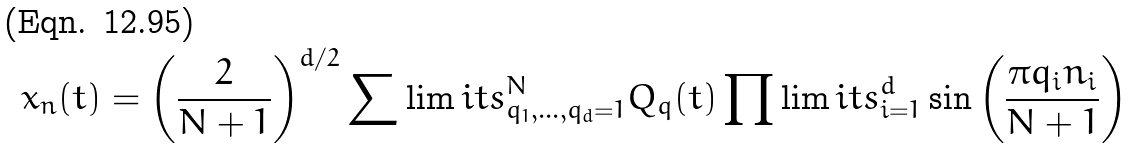<formula> <loc_0><loc_0><loc_500><loc_500>x _ { n } ( t ) = \left ( \frac { 2 } { N + 1 } \right ) ^ { d / 2 } \sum \lim i t s _ { q _ { 1 } , \dots , q _ { d } = 1 } ^ { N } Q _ { q } ( t ) \prod \lim i t s _ { i = 1 } ^ { d } \sin { \left ( \frac { \pi q _ { i } n _ { i } } { N + 1 } \right ) }</formula> 